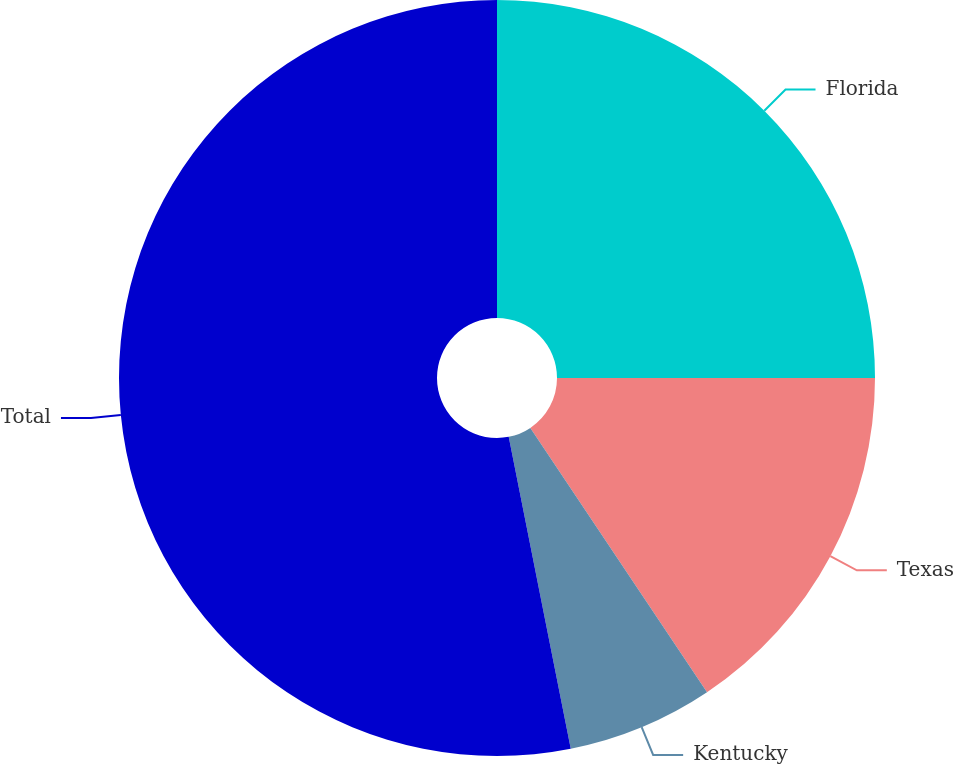Convert chart. <chart><loc_0><loc_0><loc_500><loc_500><pie_chart><fcel>Florida<fcel>Texas<fcel>Kentucky<fcel>Total<nl><fcel>25.0%<fcel>15.62%<fcel>6.25%<fcel>53.12%<nl></chart> 